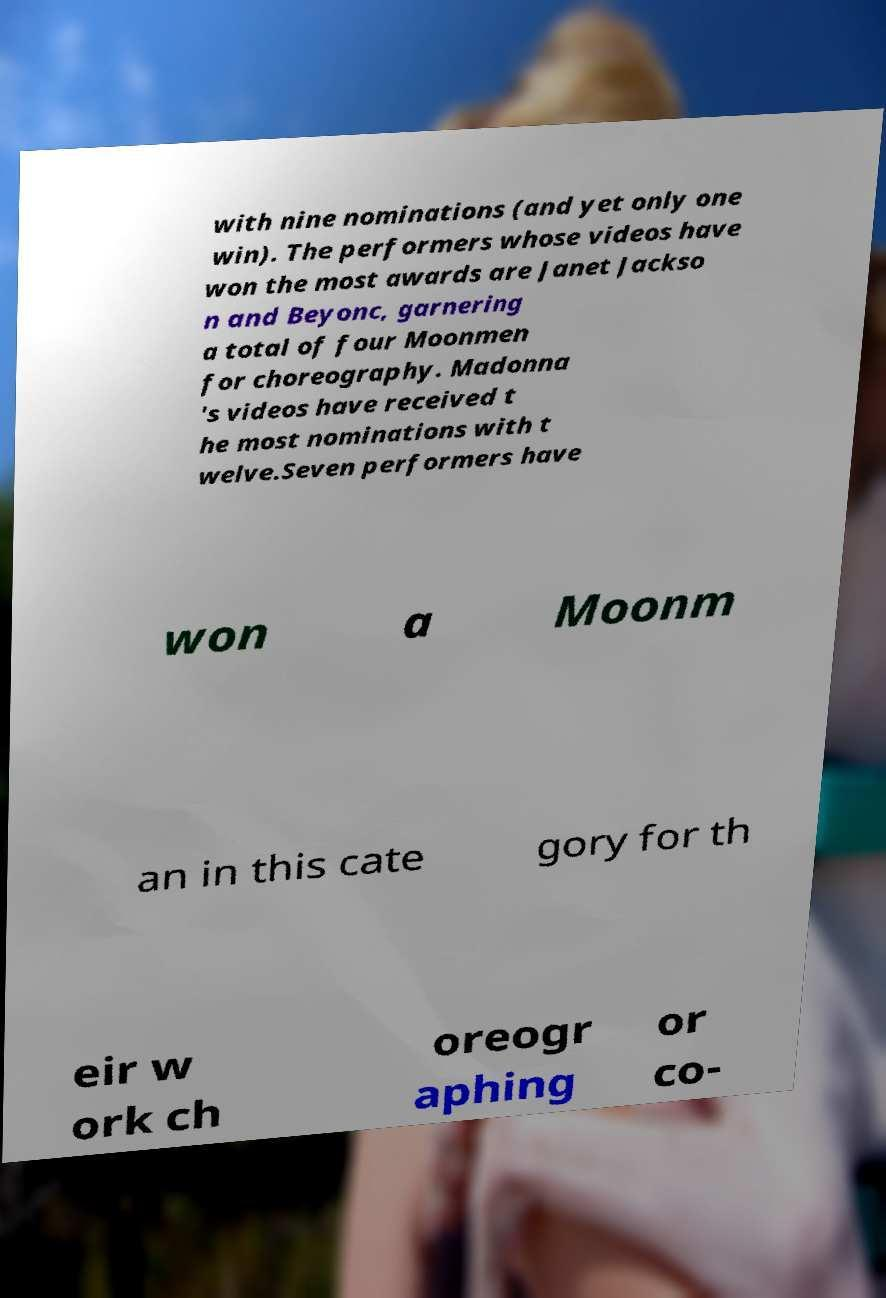For documentation purposes, I need the text within this image transcribed. Could you provide that? with nine nominations (and yet only one win). The performers whose videos have won the most awards are Janet Jackso n and Beyonc, garnering a total of four Moonmen for choreography. Madonna 's videos have received t he most nominations with t welve.Seven performers have won a Moonm an in this cate gory for th eir w ork ch oreogr aphing or co- 